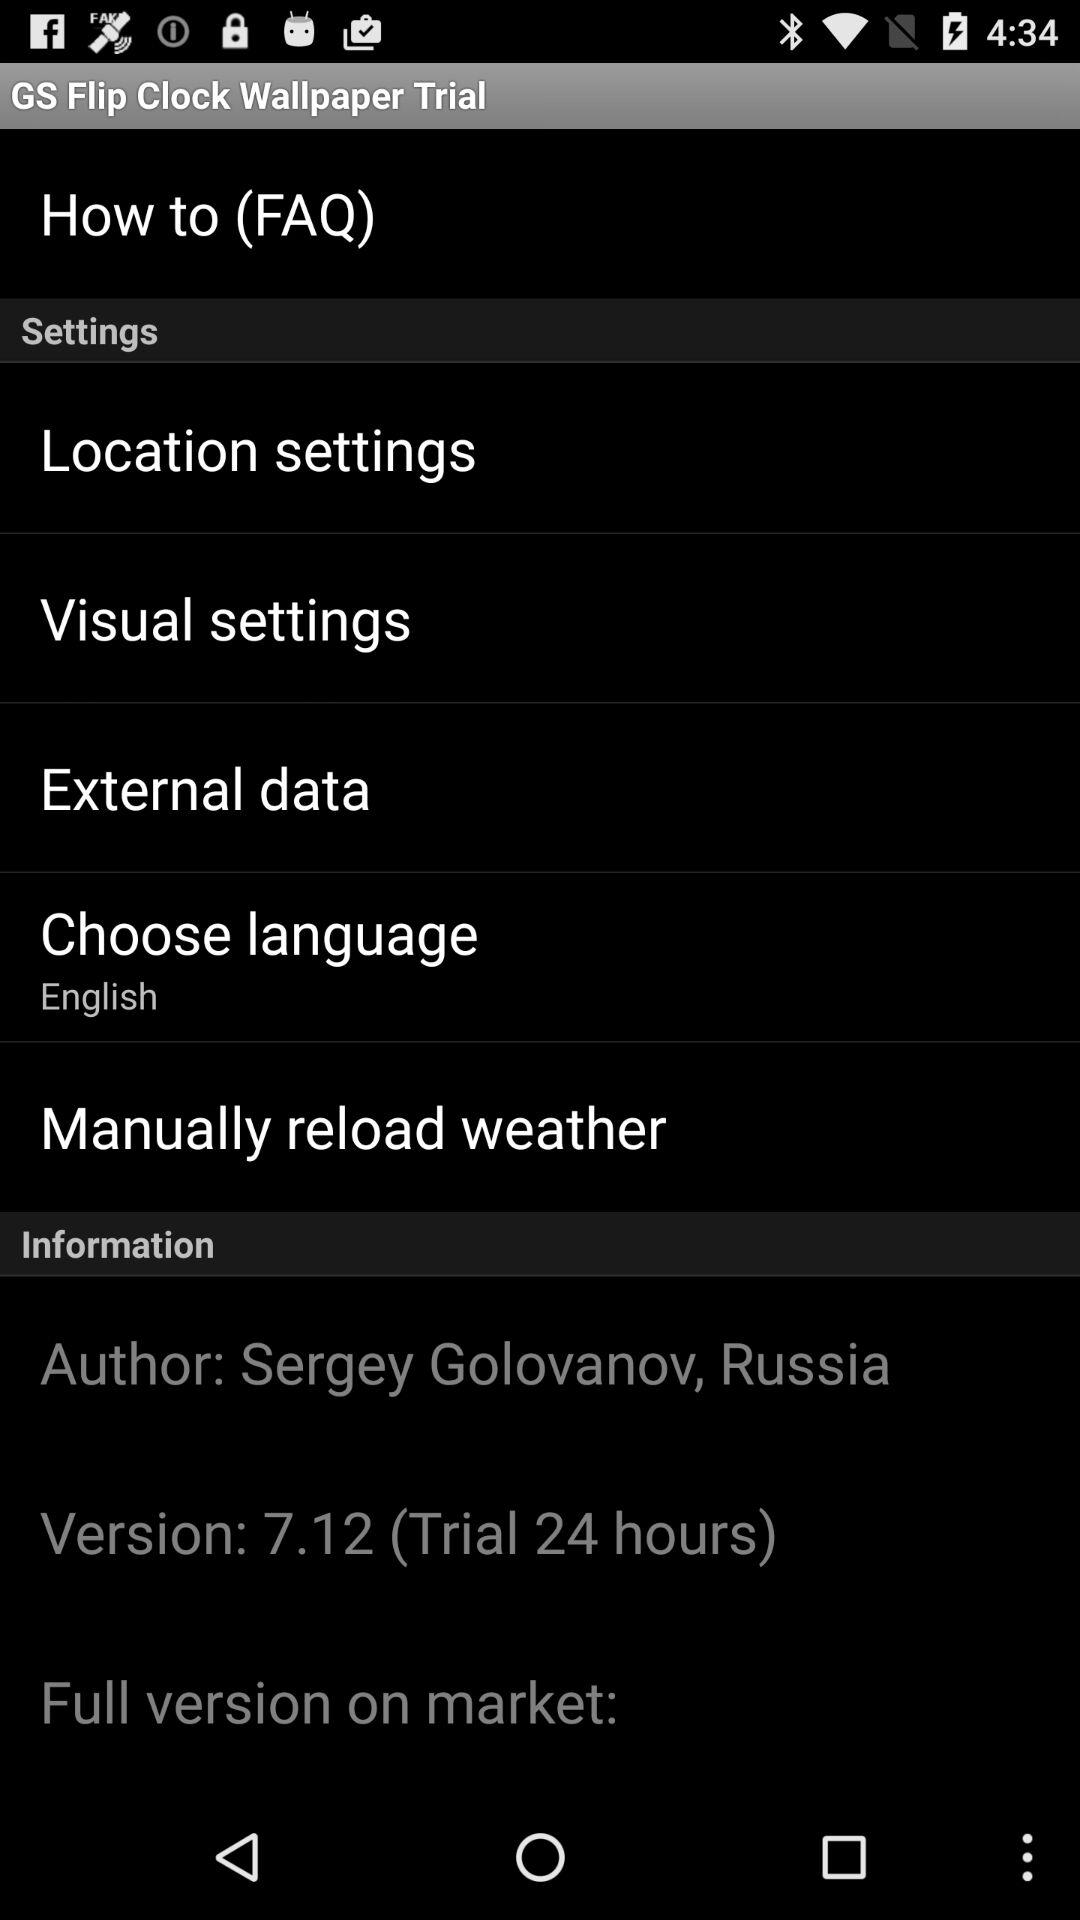Which language is selected? The selected language is English. 